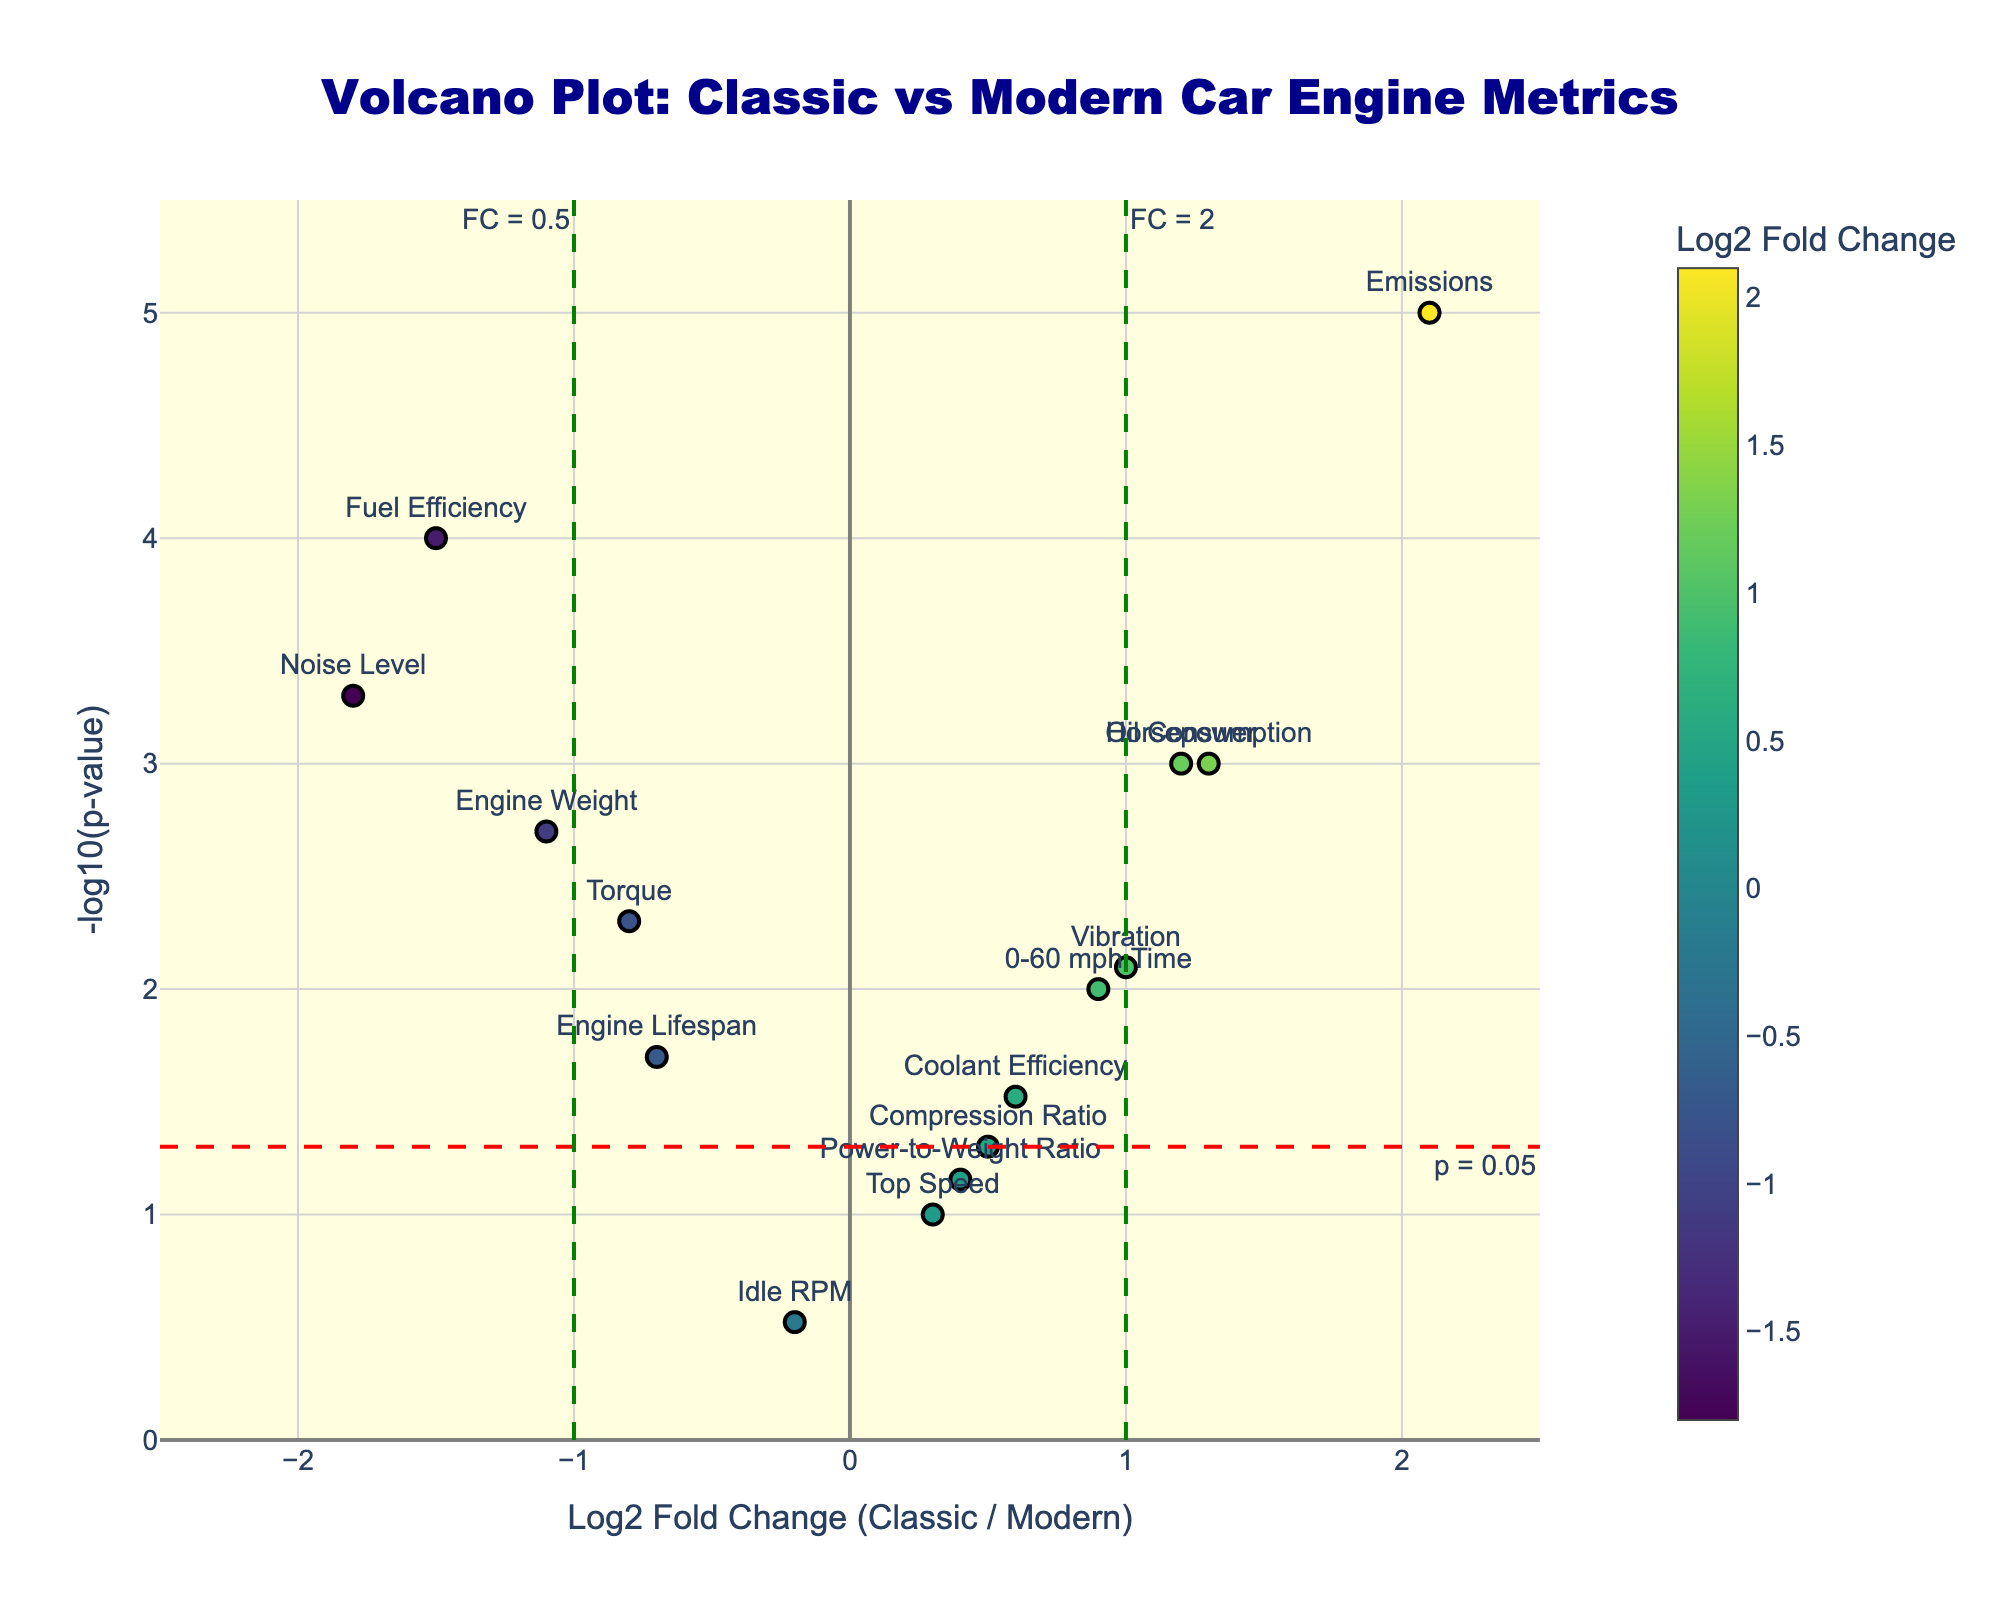What is the title of the plot? The title of the plot can be found at the top center of the figure.
Answer: Volcano Plot: Classic vs Modern Car Engine Metrics How many engine metrics have a p-value less than 0.05? Engine metrics with a p-value less than 0.05 will be above the horizontal red dashed line labeled "p = 0.05." Count the number of points that appear above this line.
Answer: 11 Which engine metric has the highest Log2 Fold Change? Look for the data point with the highest x-axis value. This point represents the highest Log2 Fold Change. It also has a color indicating high values.
Answer: Emissions What is the Log2 Fold Change and p-value of 'Fuel Efficiency'? Identify the 'Fuel Efficiency' label among the data points, then note its position on the x-axis (Log2 Fold Change) and y-axis (-log10(p-value)). Convert y-axis value back to p-value using 10^(-y).
Answer: Log2 FC: -1.5, p-value: 0.0001 Which engine metric is the closest to the significance threshold on the vertical axis? Find the point closest to the horizontal line at y = -log10(0.05) on the plot. This point represents the metric closest to having a p-value of 0.05.
Answer: Compression Ratio What's the range of Log2 Fold Change values in the plot? Determine the minimum and maximum x-axis values among all data points to identify the range of Log2 Fold Change.
Answer: -1.8 to 2.1 Which metric has the smallest p-value (most significant)? Identify the point that has the highest value on the y-axis (-log10(p-value)), which indicates the smallest original p-value.
Answer: Emissions How many points fall within the region of Log2 Fold Change between -1 and 1? Count the number of points that lie within the vertical dashed lines positioned at x = -1 and x = 1. These lines represent the specified Log2 Fold Change thresholds.
Answer: 6 What does the horizontal red line at approximately y = 1.301 represent? The horizontal red dashed line indicates a threshold, identified by its label.
Answer: p = 0.05 Which engine metric is closest to the origin (0,0) of the plot? Determine the point that is nearest to the intersection of x = 0 and y = 0, representing the origin.
Answer: Idle RPM 